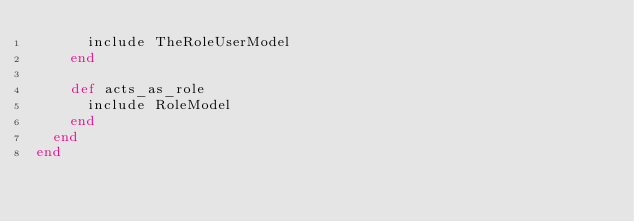Convert code to text. <code><loc_0><loc_0><loc_500><loc_500><_Ruby_>      include TheRoleUserModel
    end

    def acts_as_role
      include RoleModel
    end
  end
end</code> 